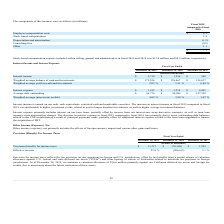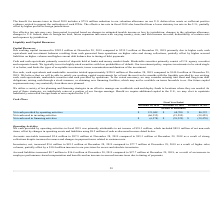According to Formfactor's financial document, How much is the valuation allowance maintained As of December 28, 2019? According to the financial document, $36.6 million. The relevant text states: "ber 28, 2019, we maintain a valuation allowance of $36.6 million primarily against our California deferred tax assets and foreign tax credits, due to uncertainty abo..." Also, can you calculate: What is the change in Provision (benefit) for income taxes from Fiscal Year Ended December 28, 2019 to December 29, 2018? Based on the calculation: 11,717-(70,109), the result is 81826 (in thousands). This is based on the information: "Provision (benefit) for income taxes $ 11,717 $ (70,109) $ 1,293 Provision (benefit) for income taxes $ 11,717 $ (70,109) $ 1,293..." The key data points involved are: 11,717, 70,109. Also, can you calculate: What is the change in Provision (benefit) for income taxes from Fiscal Year Ended December 29, 2018 to December 30, 2017? Based on the calculation: (70,109)-1,293, the result is -71402 (in thousands). This is based on the information: "Provision (benefit) for income taxes $ 11,717 $ (70,109) $ 1,293 (benefit) for income taxes $ 11,717 $ (70,109) $ 1,293..." The key data points involved are: 1,293, 70,109. Additionally, In which year was Provision (benefit) for income taxes greater than 10,000 thousands? According to the financial document, 2019. The relevant text states: "December 28, 2019 December 29, 2018 December 30, 2017..." Also, What was the Effective tax rate in 2018 and 2017 respectively? The document shows two values: (206.6) % and 3.1 % (percentage). From the document: "Effective tax rate 22.9 % (206.6)% 3.1 %..." Also, What was the reduction to valuation allowance in 2018? According to the financial document, $75.8 million. The relevant text states: "benefit for income taxes in fiscal 2018 includes a $75.8 million reduction to our valuation allowance on our U.S. deferred tax assets as sufficient positive evidence..." 